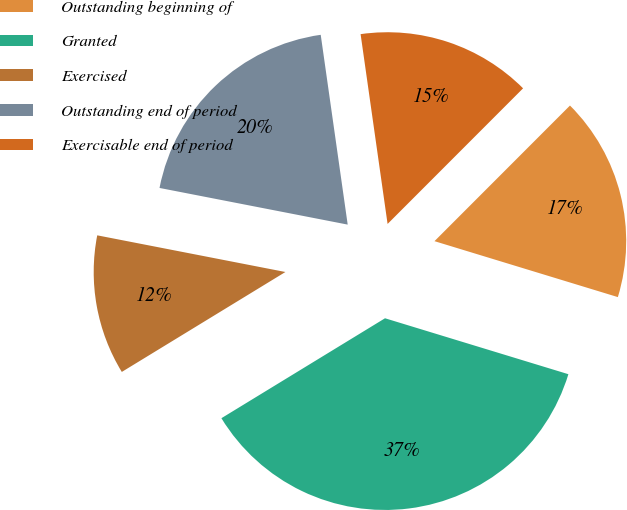<chart> <loc_0><loc_0><loc_500><loc_500><pie_chart><fcel>Outstanding beginning of<fcel>Granted<fcel>Exercised<fcel>Outstanding end of period<fcel>Exercisable end of period<nl><fcel>17.22%<fcel>36.56%<fcel>11.79%<fcel>19.69%<fcel>14.74%<nl></chart> 